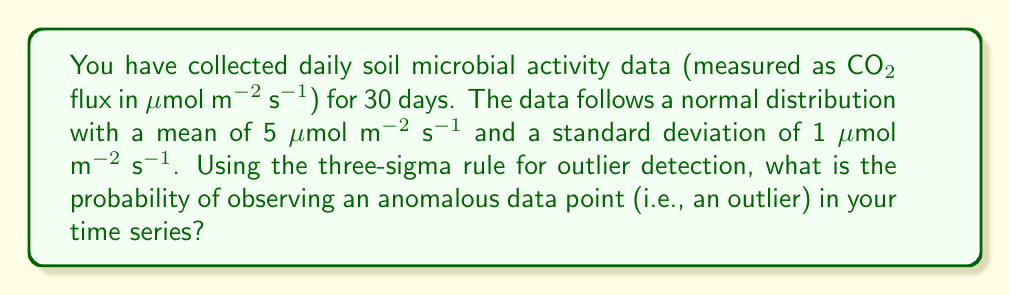Can you solve this math problem? To solve this problem, we'll follow these steps:

1) Recall the three-sigma rule: An observation is considered an outlier if it falls more than three standard deviations away from the mean in either direction.

2) Given:
   - Mean (μ) = 5 μmol m⁻² s⁻¹
   - Standard deviation (σ) = 1 μmol m⁻² s⁻¹

3) Calculate the upper and lower bounds for non-outlier data:
   - Upper bound = μ + 3σ = 5 + 3(1) = 8 μmol m⁻² s⁻¹
   - Lower bound = μ - 3σ = 5 - 3(1) = 2 μmol m⁻² s⁻¹

4) For a normal distribution, we can use the empirical rule (68-95-99.7 rule) to determine the probability:
   - 68% of the data falls within 1σ of the mean
   - 95% of the data falls within 2σ of the mean
   - 99.7% of the data falls within 3σ of the mean

5) Therefore, the probability of a data point falling within 3σ of the mean is 0.997.

6) The probability of an outlier is the complement of this probability:
   
   $$P(\text{outlier}) = 1 - 0.997 = 0.003$$

7) Convert to a percentage:
   0.003 * 100 = 0.3%

Thus, there is a 0.3% chance of observing an anomalous data point (outlier) in the time series.
Answer: 0.3% 